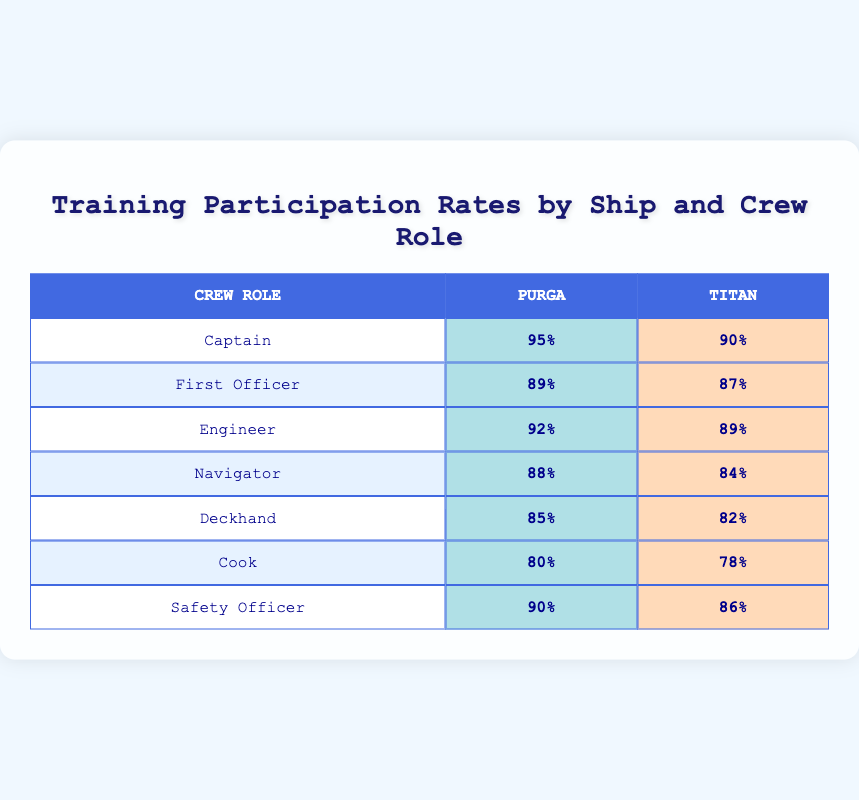What is the training participation rate for the Captain on the Purga? The table shows that the training participation rate for the Captain on the Purga is listed directly in the "Purga" column under the "Captain" row, which is 95%.
Answer: 95% Which crew role has the highest training participation rate on the Titan? From the table, the training participation rates for each crew role on the Titan are 90% (Captain), 87% (First Officer), 89% (Engineer), 84% (Navigator), 82% (Deckhand), 78% (Cook), and 86% (Safety Officer). The highest value is 90% for the Captain.
Answer: 90% What is the difference in training participation rates between the Safety Officer roles on the two ships? The Safety Officer's participation rate on the Purga is 90% and on the Titan is 86%. The difference is calculated as 90% - 86% = 4%.
Answer: 4% Is the training participation rate for Deckhands on the Purga higher than on the Titan? The table indicates that the participation rate for Deckhands on the Purga is 85%, while on the Titan it is 82%. Since 85% is greater than 82%, the statement is true.
Answer: Yes What is the average training participation rate for Engineers on both ships? The training participation rate for Engineers is 92% on the Purga and 89% on the Titan. The average is calculated as (92 + 89) / 2 = 90.5%.
Answer: 90.5% Which crew role has the lowest training participation rate on the Purga? By examining the "Purga" column, the lowest training participation rate is found for the Cook role at 80%, as it is lower than the other roles listed.
Answer: Cook Are there more crew roles with a training participation rate above 85% on the Purga than on the Titan? On the Purga, the roles above 85% are Captain (95%), First Officer (89%), Engineer (92%), Safety Officer (90%), and Deckhand (85%), totaling 5 roles. On the Titan, the roles above 85% are Captain (90%), Engineer (89%), and Safety Officer (86%), totaling 3 roles. Since 5 is greater than 3, the statement is true.
Answer: Yes What is the range of training participation rates for Crew Roles on the Purga? The participation rates on the Purga range from 80% (Cook) to 95% (Captain). The range is calculated as 95% - 80% = 15%.
Answer: 15% If you combined the participation rates for the First Officer role from both ships, what would that total be? The First Officer's training participation rate on the Purga is 89% and on the Titan it is 87%. The total is calculated as 89% + 87% = 176%.
Answer: 176% 